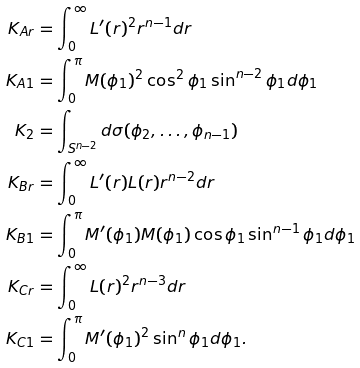<formula> <loc_0><loc_0><loc_500><loc_500>K _ { A r } & = \int _ { 0 } ^ { \infty } L ^ { \prime } ( r ) ^ { 2 } r ^ { n - 1 } d r \\ K _ { A 1 } & = \int _ { 0 } ^ { \pi } M ( \phi _ { 1 } ) ^ { 2 } \cos ^ { 2 } \phi _ { 1 } \sin ^ { n - 2 } \phi _ { 1 } d \phi _ { 1 } \\ K _ { 2 } & = \int _ { S ^ { n - 2 } } d \sigma ( \phi _ { 2 } , \dots , \phi _ { n - 1 } ) \\ K _ { B r } & = \int _ { 0 } ^ { \infty } L ^ { \prime } ( r ) L ( r ) r ^ { n - 2 } d r \\ K _ { B 1 } & = \int _ { 0 } ^ { \pi } M ^ { \prime } ( \phi _ { 1 } ) M ( \phi _ { 1 } ) \cos \phi _ { 1 } \sin ^ { n - 1 } \phi _ { 1 } d \phi _ { 1 } \\ K _ { C r } & = \int _ { 0 } ^ { \infty } L ( r ) ^ { 2 } r ^ { n - 3 } d r \\ K _ { C 1 } & = \int _ { 0 } ^ { \pi } M ^ { \prime } ( \phi _ { 1 } ) ^ { 2 } \sin ^ { n } \phi _ { 1 } d \phi _ { 1 } .</formula> 